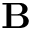<formula> <loc_0><loc_0><loc_500><loc_500>B</formula> 